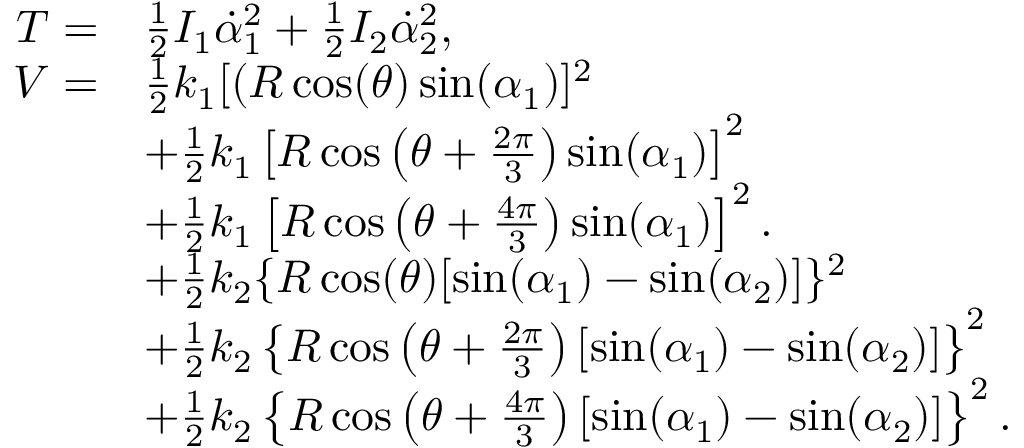<formula> <loc_0><loc_0><loc_500><loc_500>\begin{array} { r l } { T = } & { \frac { 1 } { 2 } I _ { 1 } \dot { \alpha } _ { 1 } ^ { 2 } + \frac { 1 } { 2 } I _ { 2 } \dot { \alpha } _ { 2 } ^ { 2 } , } \\ { V = } & { \frac { 1 } { 2 } k _ { 1 } [ ( R \cos ( \theta ) \sin ( \alpha _ { 1 } ) ] ^ { 2 } } \\ & { + \frac { 1 } { 2 } k _ { 1 } \left [ R \cos \left ( \theta + \frac { 2 \pi } { 3 } \right ) \sin ( \alpha _ { 1 } ) \right ] ^ { 2 } } \\ & { + \frac { 1 } { 2 } k _ { 1 } \left [ R \cos \left ( \theta + \frac { 4 \pi } { 3 } \right ) \sin ( \alpha _ { 1 } ) \right ] ^ { 2 } . } \\ & { + \frac { 1 } { 2 } k _ { 2 } \{ R \cos ( \theta ) [ \sin ( \alpha _ { 1 } ) - \sin ( \alpha _ { 2 } ) ] \} ^ { 2 } } \\ & { + \frac { 1 } { 2 } k _ { 2 } \left \{ R \cos \left ( \theta + \frac { 2 \pi } { 3 } \right ) [ \sin ( \alpha _ { 1 } ) - \sin ( \alpha _ { 2 } ) ] \right \} ^ { 2 } } \\ & { + \frac { 1 } { 2 } k _ { 2 } \left \{ R \cos \left ( \theta + \frac { 4 \pi } { 3 } \right ) [ \sin ( \alpha _ { 1 } ) - \sin ( \alpha _ { 2 } ) ] \right \} ^ { 2 } . } \end{array}</formula> 